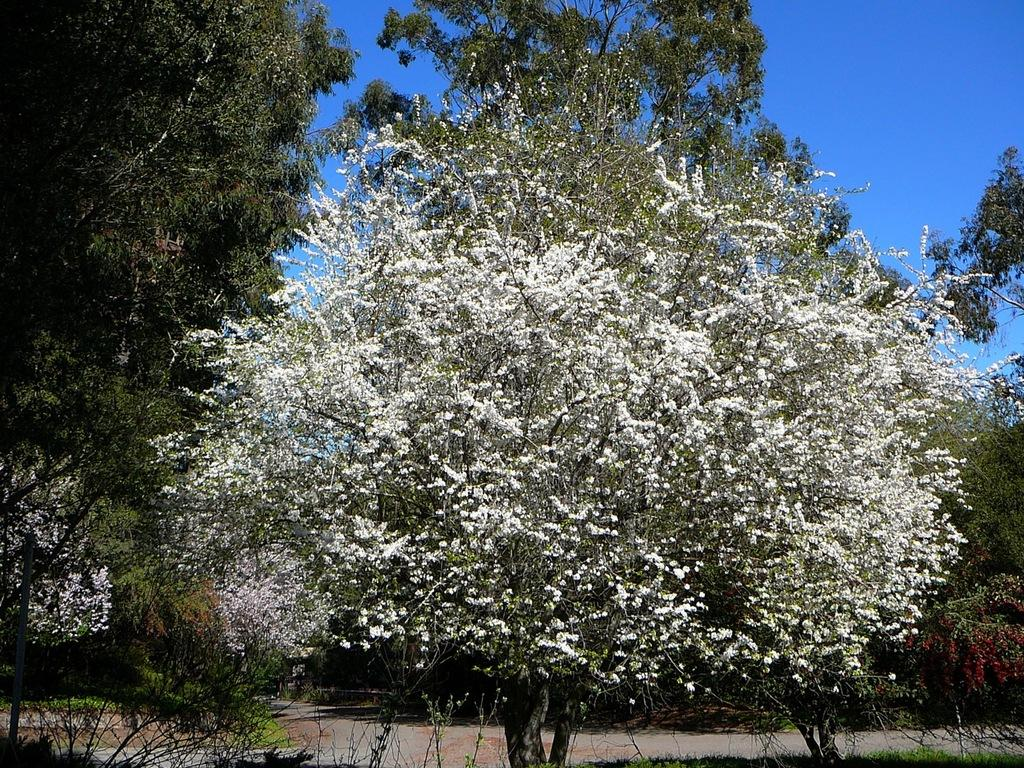What is the primary feature of the image? There are a lot of trees in the image. Can you describe the landscape in the image? The landscape is dominated by trees. What type of vegetation is visible in the image? The vegetation in the image consists mainly of trees. What color is the ink used to write on the trees in the image? There is no ink or writing present on the trees in the image. Is there a poisonous substance visible on the trees in the image? There is no mention of any poisonous substance in the image. Can you see an umbrella in the image? There is no umbrella present in the image. 